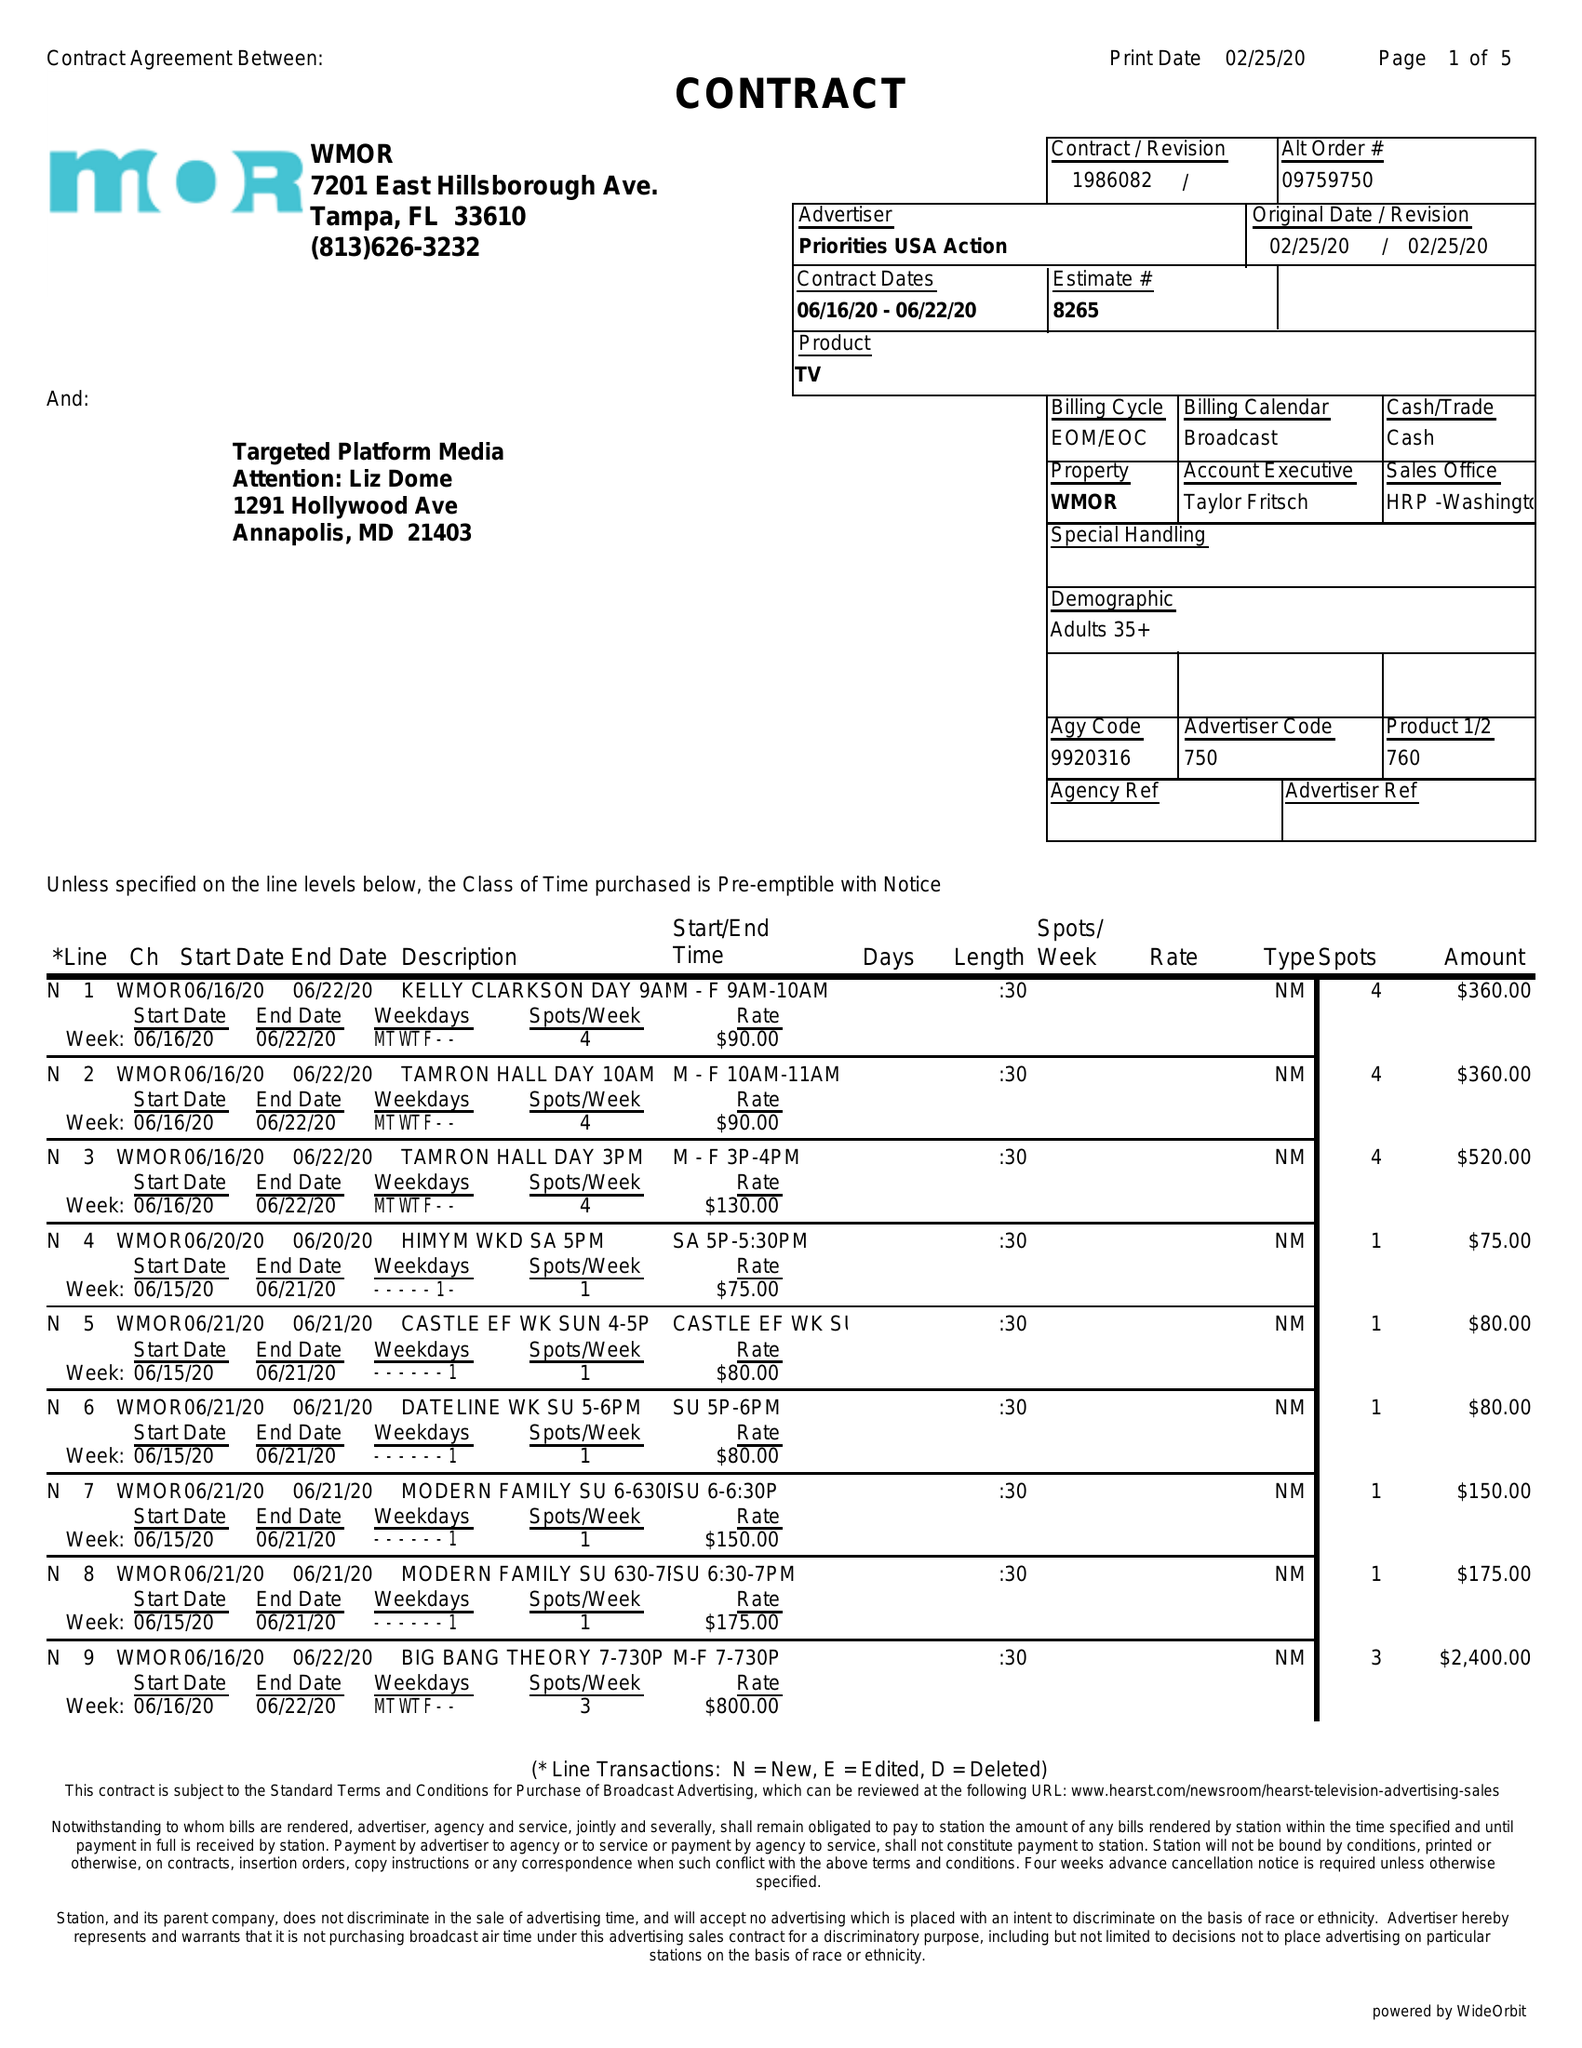What is the value for the gross_amount?
Answer the question using a single word or phrase. 10045.00 